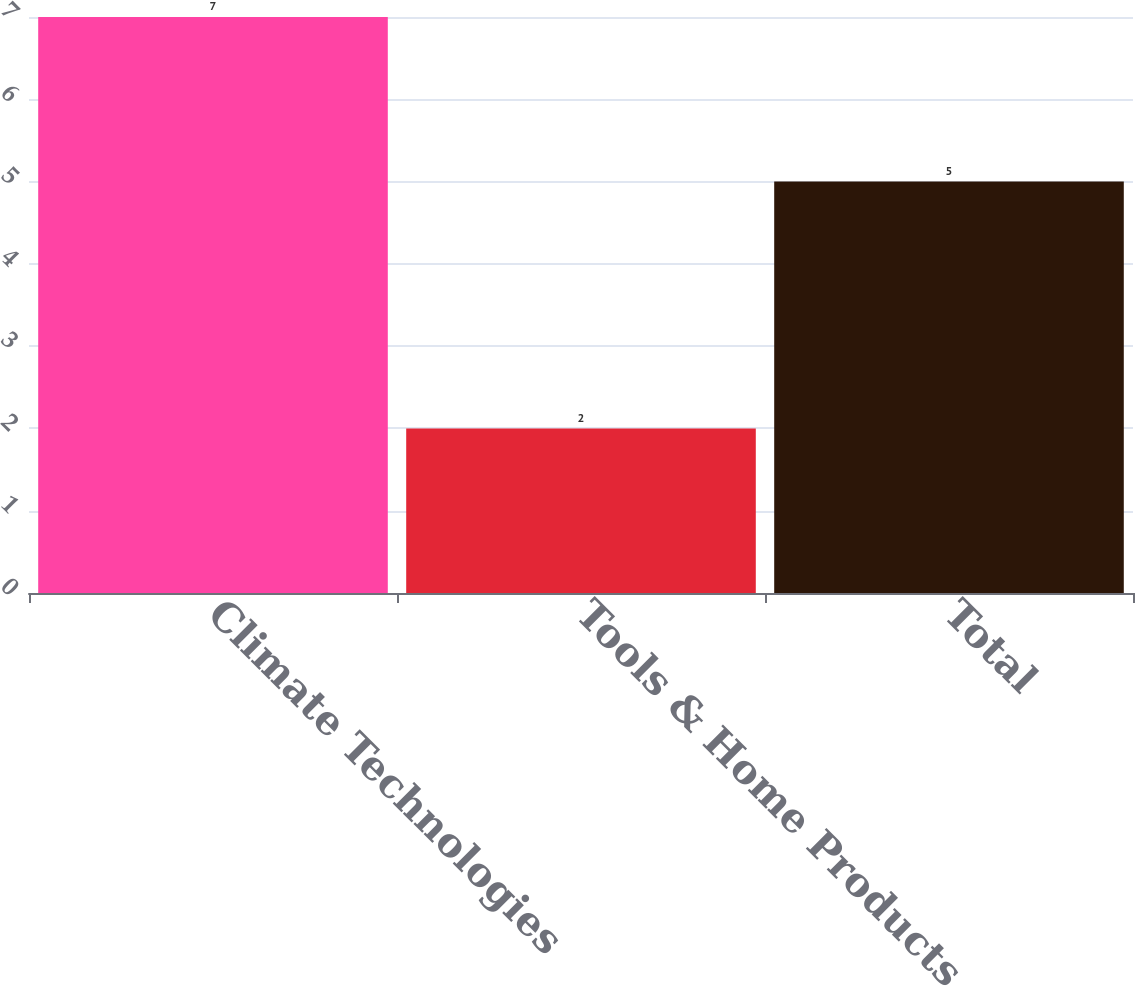Convert chart to OTSL. <chart><loc_0><loc_0><loc_500><loc_500><bar_chart><fcel>Climate Technologies<fcel>Tools & Home Products<fcel>Total<nl><fcel>7<fcel>2<fcel>5<nl></chart> 